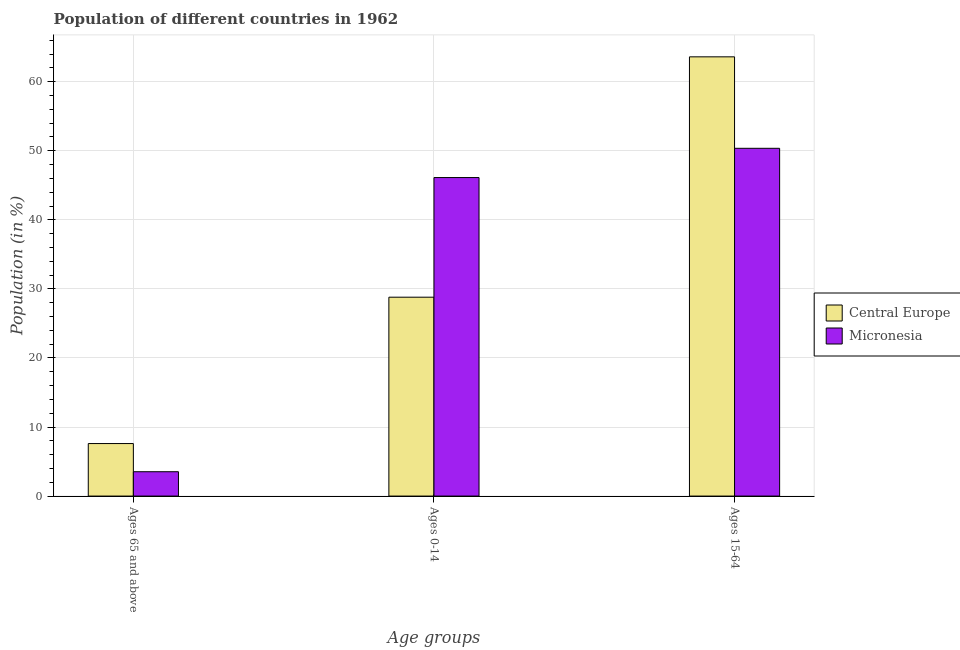How many different coloured bars are there?
Provide a succinct answer. 2. What is the label of the 1st group of bars from the left?
Offer a very short reply. Ages 65 and above. What is the percentage of population within the age-group 15-64 in Central Europe?
Your response must be concise. 63.6. Across all countries, what is the maximum percentage of population within the age-group 0-14?
Your response must be concise. 46.12. Across all countries, what is the minimum percentage of population within the age-group 15-64?
Ensure brevity in your answer.  50.36. In which country was the percentage of population within the age-group 15-64 maximum?
Ensure brevity in your answer.  Central Europe. In which country was the percentage of population within the age-group 0-14 minimum?
Provide a short and direct response. Central Europe. What is the total percentage of population within the age-group 15-64 in the graph?
Your response must be concise. 113.96. What is the difference between the percentage of population within the age-group 15-64 in Central Europe and that in Micronesia?
Offer a very short reply. 13.24. What is the difference between the percentage of population within the age-group of 65 and above in Micronesia and the percentage of population within the age-group 15-64 in Central Europe?
Provide a succinct answer. -60.08. What is the average percentage of population within the age-group 0-14 per country?
Offer a terse response. 37.46. What is the difference between the percentage of population within the age-group of 65 and above and percentage of population within the age-group 15-64 in Micronesia?
Your answer should be compact. -46.83. In how many countries, is the percentage of population within the age-group 15-64 greater than 36 %?
Provide a short and direct response. 2. What is the ratio of the percentage of population within the age-group of 65 and above in Central Europe to that in Micronesia?
Ensure brevity in your answer.  2.16. Is the difference between the percentage of population within the age-group 0-14 in Central Europe and Micronesia greater than the difference between the percentage of population within the age-group 15-64 in Central Europe and Micronesia?
Ensure brevity in your answer.  No. What is the difference between the highest and the second highest percentage of population within the age-group 0-14?
Provide a short and direct response. 17.32. What is the difference between the highest and the lowest percentage of population within the age-group of 65 and above?
Ensure brevity in your answer.  4.08. In how many countries, is the percentage of population within the age-group of 65 and above greater than the average percentage of population within the age-group of 65 and above taken over all countries?
Provide a short and direct response. 1. What does the 1st bar from the left in Ages 15-64 represents?
Offer a terse response. Central Europe. What does the 1st bar from the right in Ages 0-14 represents?
Offer a very short reply. Micronesia. How many bars are there?
Your answer should be very brief. 6. Are all the bars in the graph horizontal?
Give a very brief answer. No. How many countries are there in the graph?
Provide a succinct answer. 2. What is the difference between two consecutive major ticks on the Y-axis?
Your response must be concise. 10. Are the values on the major ticks of Y-axis written in scientific E-notation?
Offer a terse response. No. Where does the legend appear in the graph?
Your response must be concise. Center right. How many legend labels are there?
Make the answer very short. 2. How are the legend labels stacked?
Keep it short and to the point. Vertical. What is the title of the graph?
Offer a terse response. Population of different countries in 1962. What is the label or title of the X-axis?
Your answer should be very brief. Age groups. What is the label or title of the Y-axis?
Your answer should be very brief. Population (in %). What is the Population (in %) of Central Europe in Ages 65 and above?
Offer a terse response. 7.6. What is the Population (in %) of Micronesia in Ages 65 and above?
Provide a succinct answer. 3.52. What is the Population (in %) of Central Europe in Ages 0-14?
Offer a very short reply. 28.8. What is the Population (in %) in Micronesia in Ages 0-14?
Offer a terse response. 46.12. What is the Population (in %) in Central Europe in Ages 15-64?
Provide a succinct answer. 63.6. What is the Population (in %) of Micronesia in Ages 15-64?
Your answer should be very brief. 50.36. Across all Age groups, what is the maximum Population (in %) in Central Europe?
Your response must be concise. 63.6. Across all Age groups, what is the maximum Population (in %) in Micronesia?
Offer a very short reply. 50.36. Across all Age groups, what is the minimum Population (in %) of Central Europe?
Your answer should be compact. 7.6. Across all Age groups, what is the minimum Population (in %) in Micronesia?
Ensure brevity in your answer.  3.52. What is the total Population (in %) of Central Europe in the graph?
Provide a succinct answer. 100. What is the difference between the Population (in %) in Central Europe in Ages 65 and above and that in Ages 0-14?
Give a very brief answer. -21.19. What is the difference between the Population (in %) of Micronesia in Ages 65 and above and that in Ages 0-14?
Your answer should be very brief. -42.6. What is the difference between the Population (in %) of Central Europe in Ages 65 and above and that in Ages 15-64?
Give a very brief answer. -56. What is the difference between the Population (in %) of Micronesia in Ages 65 and above and that in Ages 15-64?
Your answer should be very brief. -46.83. What is the difference between the Population (in %) in Central Europe in Ages 0-14 and that in Ages 15-64?
Give a very brief answer. -34.8. What is the difference between the Population (in %) in Micronesia in Ages 0-14 and that in Ages 15-64?
Your answer should be compact. -4.24. What is the difference between the Population (in %) in Central Europe in Ages 65 and above and the Population (in %) in Micronesia in Ages 0-14?
Your answer should be very brief. -38.52. What is the difference between the Population (in %) in Central Europe in Ages 65 and above and the Population (in %) in Micronesia in Ages 15-64?
Your answer should be compact. -42.75. What is the difference between the Population (in %) of Central Europe in Ages 0-14 and the Population (in %) of Micronesia in Ages 15-64?
Provide a succinct answer. -21.56. What is the average Population (in %) of Central Europe per Age groups?
Your answer should be compact. 33.33. What is the average Population (in %) in Micronesia per Age groups?
Offer a very short reply. 33.33. What is the difference between the Population (in %) in Central Europe and Population (in %) in Micronesia in Ages 65 and above?
Your answer should be very brief. 4.08. What is the difference between the Population (in %) in Central Europe and Population (in %) in Micronesia in Ages 0-14?
Ensure brevity in your answer.  -17.32. What is the difference between the Population (in %) in Central Europe and Population (in %) in Micronesia in Ages 15-64?
Your answer should be compact. 13.24. What is the ratio of the Population (in %) in Central Europe in Ages 65 and above to that in Ages 0-14?
Offer a terse response. 0.26. What is the ratio of the Population (in %) of Micronesia in Ages 65 and above to that in Ages 0-14?
Offer a terse response. 0.08. What is the ratio of the Population (in %) in Central Europe in Ages 65 and above to that in Ages 15-64?
Your answer should be very brief. 0.12. What is the ratio of the Population (in %) in Micronesia in Ages 65 and above to that in Ages 15-64?
Provide a succinct answer. 0.07. What is the ratio of the Population (in %) of Central Europe in Ages 0-14 to that in Ages 15-64?
Make the answer very short. 0.45. What is the ratio of the Population (in %) in Micronesia in Ages 0-14 to that in Ages 15-64?
Your answer should be very brief. 0.92. What is the difference between the highest and the second highest Population (in %) of Central Europe?
Your response must be concise. 34.8. What is the difference between the highest and the second highest Population (in %) in Micronesia?
Your response must be concise. 4.24. What is the difference between the highest and the lowest Population (in %) in Central Europe?
Keep it short and to the point. 56. What is the difference between the highest and the lowest Population (in %) of Micronesia?
Make the answer very short. 46.83. 